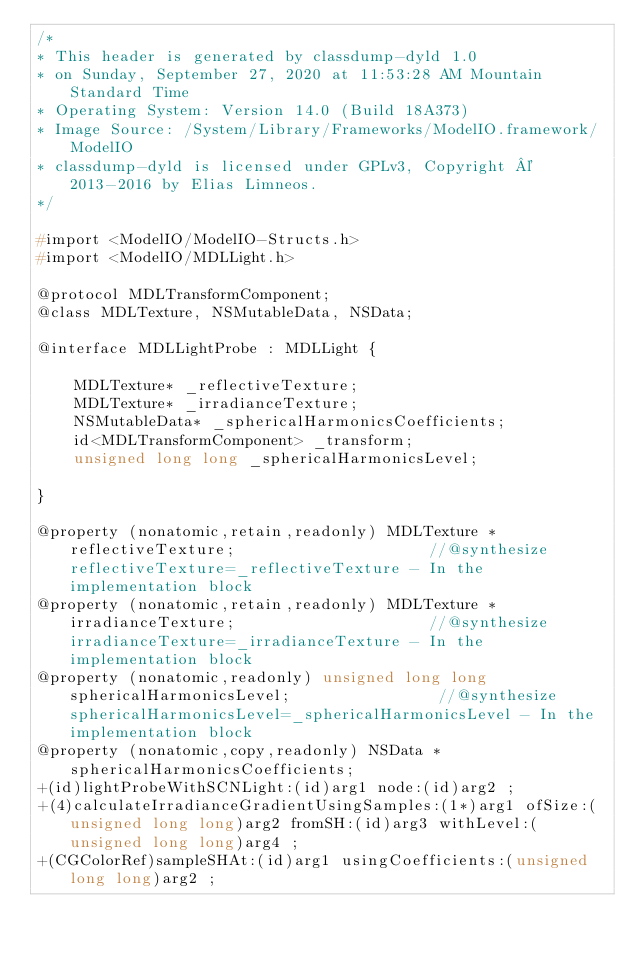<code> <loc_0><loc_0><loc_500><loc_500><_C_>/*
* This header is generated by classdump-dyld 1.0
* on Sunday, September 27, 2020 at 11:53:28 AM Mountain Standard Time
* Operating System: Version 14.0 (Build 18A373)
* Image Source: /System/Library/Frameworks/ModelIO.framework/ModelIO
* classdump-dyld is licensed under GPLv3, Copyright © 2013-2016 by Elias Limneos.
*/

#import <ModelIO/ModelIO-Structs.h>
#import <ModelIO/MDLLight.h>

@protocol MDLTransformComponent;
@class MDLTexture, NSMutableData, NSData;

@interface MDLLightProbe : MDLLight {

	MDLTexture* _reflectiveTexture;
	MDLTexture* _irradianceTexture;
	NSMutableData* _sphericalHarmonicsCoefficients;
	id<MDLTransformComponent> _transform;
	unsigned long long _sphericalHarmonicsLevel;

}

@property (nonatomic,retain,readonly) MDLTexture * reflectiveTexture;                     //@synthesize reflectiveTexture=_reflectiveTexture - In the implementation block
@property (nonatomic,retain,readonly) MDLTexture * irradianceTexture;                     //@synthesize irradianceTexture=_irradianceTexture - In the implementation block
@property (nonatomic,readonly) unsigned long long sphericalHarmonicsLevel;                //@synthesize sphericalHarmonicsLevel=_sphericalHarmonicsLevel - In the implementation block
@property (nonatomic,copy,readonly) NSData * sphericalHarmonicsCoefficients; 
+(id)lightProbeWithSCNLight:(id)arg1 node:(id)arg2 ;
+(4)calculateIrradianceGradientUsingSamples:(1*)arg1 ofSize:(unsigned long long)arg2 fromSH:(id)arg3 withLevel:(unsigned long long)arg4 ;
+(CGColorRef)sampleSHAt:(id)arg1 usingCoefficients:(unsigned long long)arg2 ;</code> 